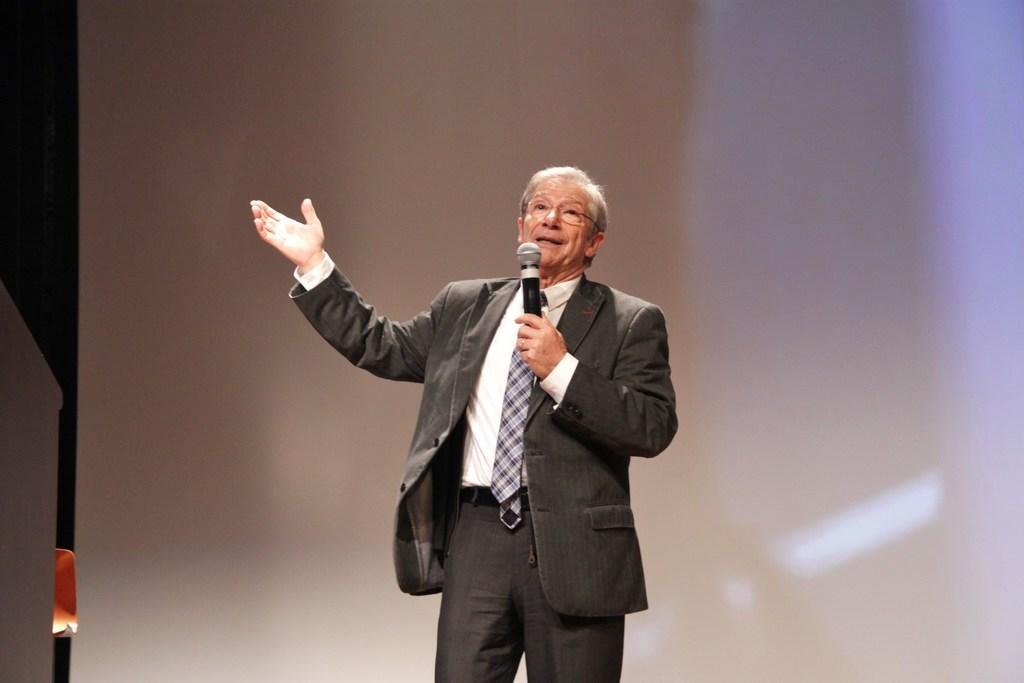Describe this image in one or two sentences. The person wearing suit is standing and speaking in front of a mic and the background is white in color. 